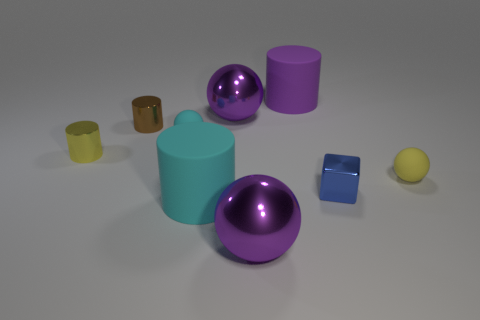There is a large cylinder that is behind the tiny object on the right side of the blue block; what color is it?
Give a very brief answer. Purple. What number of rubber objects are either big gray blocks or tiny yellow cylinders?
Your response must be concise. 0. Does the purple cylinder have the same material as the blue cube?
Offer a terse response. No. What material is the big cylinder that is behind the big rubber thing to the left of the purple matte object made of?
Make the answer very short. Rubber. How many small things are yellow cylinders or spheres?
Your answer should be compact. 3. What is the size of the purple cylinder?
Provide a short and direct response. Large. Is the number of large rubber things in front of the blue thing greater than the number of cubes?
Provide a succinct answer. No. Are there the same number of yellow metal things right of the purple cylinder and brown shiny things that are in front of the tiny cyan matte ball?
Offer a very short reply. Yes. The sphere that is both in front of the tiny yellow metallic object and to the left of the purple rubber cylinder is what color?
Your answer should be very brief. Purple. Are there more big balls in front of the tiny brown cylinder than yellow things that are in front of the yellow ball?
Your response must be concise. Yes. 